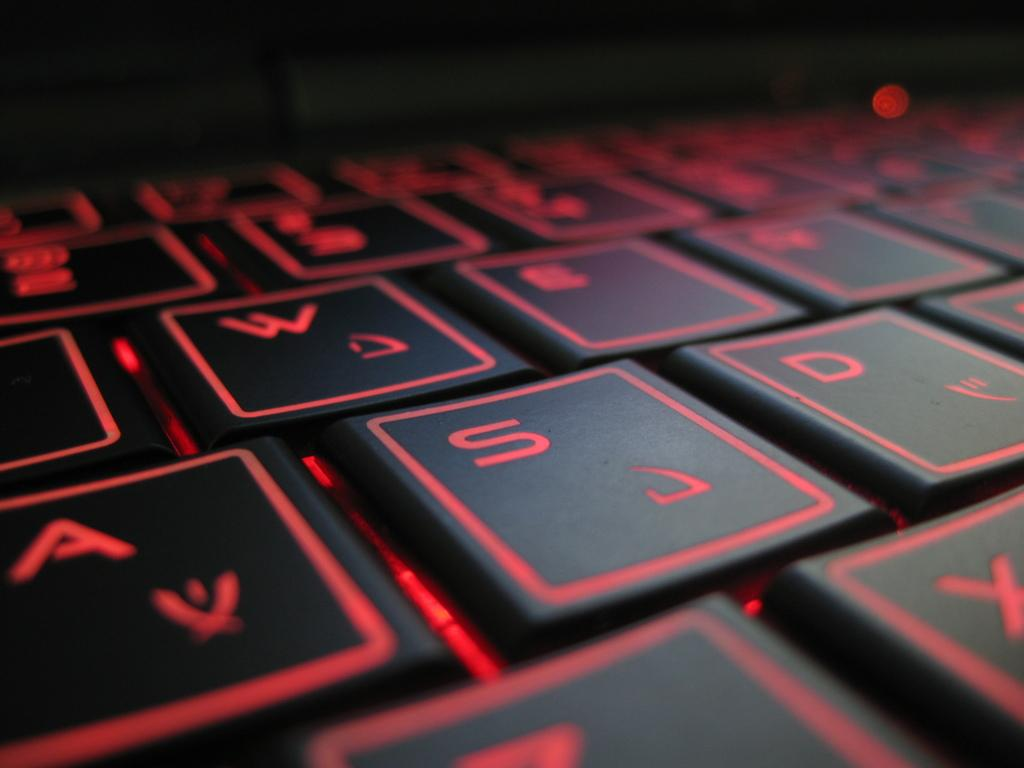Provide a one-sentence caption for the provided image. A black laptop keyboard where visible keys include A, S, D, and W. 